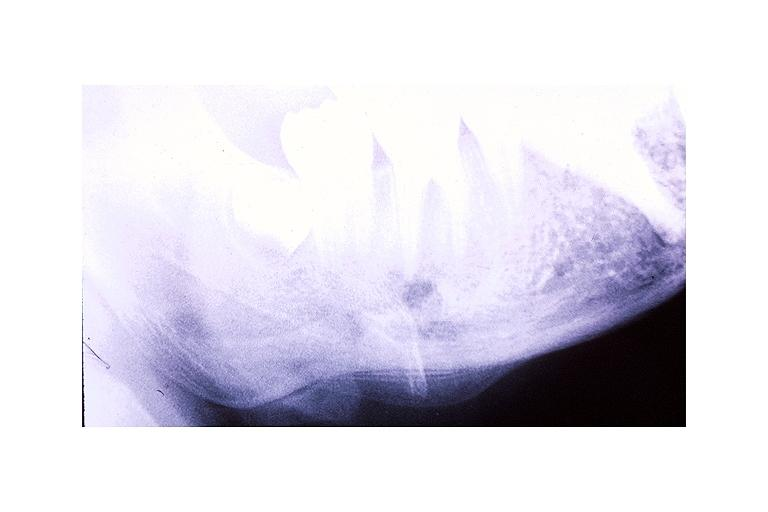does this image show garres osteomyelitis proliferative periosteitis?
Answer the question using a single word or phrase. Yes 